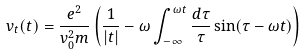<formula> <loc_0><loc_0><loc_500><loc_500>v _ { t } ( t ) = \frac { e ^ { 2 } } { v _ { 0 } ^ { 2 } m } \left ( \frac { 1 } { | t | } - \omega \int _ { - \infty } ^ { \omega t } \frac { d \tau } { \tau } \sin ( \tau - \omega t ) \right )</formula> 